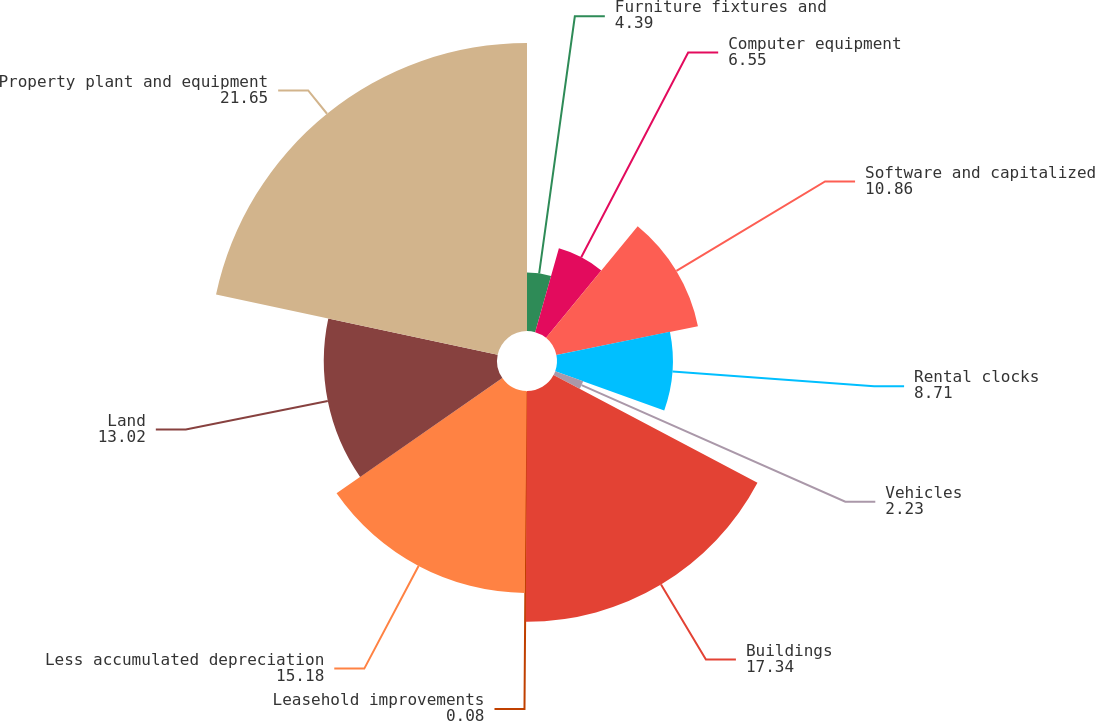<chart> <loc_0><loc_0><loc_500><loc_500><pie_chart><fcel>Furniture fixtures and<fcel>Computer equipment<fcel>Software and capitalized<fcel>Rental clocks<fcel>Vehicles<fcel>Buildings<fcel>Leasehold improvements<fcel>Less accumulated depreciation<fcel>Land<fcel>Property plant and equipment<nl><fcel>4.39%<fcel>6.55%<fcel>10.86%<fcel>8.71%<fcel>2.23%<fcel>17.34%<fcel>0.08%<fcel>15.18%<fcel>13.02%<fcel>21.65%<nl></chart> 